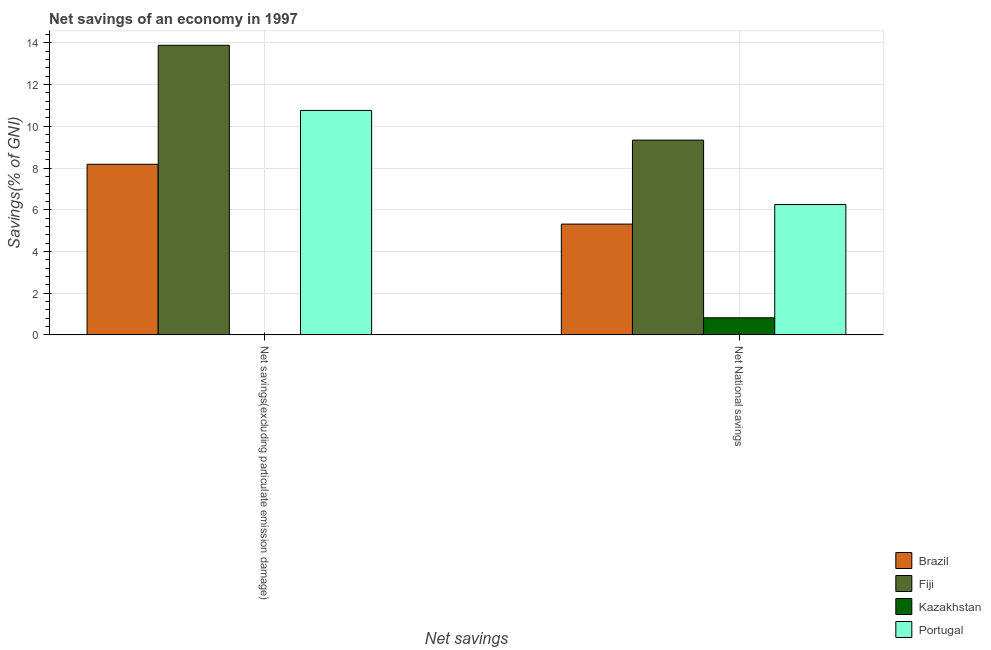How many bars are there on the 2nd tick from the left?
Your answer should be very brief. 4. How many bars are there on the 2nd tick from the right?
Offer a very short reply. 3. What is the label of the 1st group of bars from the left?
Your answer should be very brief. Net savings(excluding particulate emission damage). What is the net national savings in Fiji?
Ensure brevity in your answer.  9.34. Across all countries, what is the maximum net savings(excluding particulate emission damage)?
Your answer should be compact. 13.88. Across all countries, what is the minimum net savings(excluding particulate emission damage)?
Ensure brevity in your answer.  0. In which country was the net savings(excluding particulate emission damage) maximum?
Make the answer very short. Fiji. What is the total net savings(excluding particulate emission damage) in the graph?
Your answer should be compact. 32.82. What is the difference between the net savings(excluding particulate emission damage) in Fiji and that in Brazil?
Provide a succinct answer. 5.7. What is the difference between the net national savings in Fiji and the net savings(excluding particulate emission damage) in Portugal?
Make the answer very short. -1.42. What is the average net savings(excluding particulate emission damage) per country?
Keep it short and to the point. 8.21. What is the difference between the net savings(excluding particulate emission damage) and net national savings in Brazil?
Provide a succinct answer. 2.87. What is the ratio of the net national savings in Fiji to that in Brazil?
Ensure brevity in your answer.  1.76. Is the net national savings in Fiji less than that in Portugal?
Provide a short and direct response. No. In how many countries, is the net national savings greater than the average net national savings taken over all countries?
Provide a short and direct response. 2. How many bars are there?
Provide a short and direct response. 7. Are all the bars in the graph horizontal?
Give a very brief answer. No. Are the values on the major ticks of Y-axis written in scientific E-notation?
Offer a terse response. No. Does the graph contain grids?
Provide a short and direct response. Yes. Where does the legend appear in the graph?
Your response must be concise. Bottom right. How are the legend labels stacked?
Your response must be concise. Vertical. What is the title of the graph?
Keep it short and to the point. Net savings of an economy in 1997. What is the label or title of the X-axis?
Your response must be concise. Net savings. What is the label or title of the Y-axis?
Give a very brief answer. Savings(% of GNI). What is the Savings(% of GNI) of Brazil in Net savings(excluding particulate emission damage)?
Provide a succinct answer. 8.18. What is the Savings(% of GNI) of Fiji in Net savings(excluding particulate emission damage)?
Offer a terse response. 13.88. What is the Savings(% of GNI) of Kazakhstan in Net savings(excluding particulate emission damage)?
Your response must be concise. 0. What is the Savings(% of GNI) in Portugal in Net savings(excluding particulate emission damage)?
Your answer should be very brief. 10.76. What is the Savings(% of GNI) of Brazil in Net National savings?
Your answer should be compact. 5.31. What is the Savings(% of GNI) in Fiji in Net National savings?
Your answer should be very brief. 9.34. What is the Savings(% of GNI) of Kazakhstan in Net National savings?
Your answer should be very brief. 0.82. What is the Savings(% of GNI) of Portugal in Net National savings?
Your answer should be compact. 6.25. Across all Net savings, what is the maximum Savings(% of GNI) of Brazil?
Provide a succinct answer. 8.18. Across all Net savings, what is the maximum Savings(% of GNI) in Fiji?
Make the answer very short. 13.88. Across all Net savings, what is the maximum Savings(% of GNI) of Kazakhstan?
Your response must be concise. 0.82. Across all Net savings, what is the maximum Savings(% of GNI) of Portugal?
Offer a terse response. 10.76. Across all Net savings, what is the minimum Savings(% of GNI) of Brazil?
Ensure brevity in your answer.  5.31. Across all Net savings, what is the minimum Savings(% of GNI) in Fiji?
Keep it short and to the point. 9.34. Across all Net savings, what is the minimum Savings(% of GNI) of Kazakhstan?
Make the answer very short. 0. Across all Net savings, what is the minimum Savings(% of GNI) in Portugal?
Make the answer very short. 6.25. What is the total Savings(% of GNI) of Brazil in the graph?
Your response must be concise. 13.49. What is the total Savings(% of GNI) in Fiji in the graph?
Offer a terse response. 23.22. What is the total Savings(% of GNI) in Kazakhstan in the graph?
Your answer should be very brief. 0.82. What is the total Savings(% of GNI) of Portugal in the graph?
Provide a succinct answer. 17.01. What is the difference between the Savings(% of GNI) in Brazil in Net savings(excluding particulate emission damage) and that in Net National savings?
Make the answer very short. 2.87. What is the difference between the Savings(% of GNI) in Fiji in Net savings(excluding particulate emission damage) and that in Net National savings?
Ensure brevity in your answer.  4.55. What is the difference between the Savings(% of GNI) in Portugal in Net savings(excluding particulate emission damage) and that in Net National savings?
Give a very brief answer. 4.51. What is the difference between the Savings(% of GNI) of Brazil in Net savings(excluding particulate emission damage) and the Savings(% of GNI) of Fiji in Net National savings?
Ensure brevity in your answer.  -1.16. What is the difference between the Savings(% of GNI) of Brazil in Net savings(excluding particulate emission damage) and the Savings(% of GNI) of Kazakhstan in Net National savings?
Ensure brevity in your answer.  7.36. What is the difference between the Savings(% of GNI) in Brazil in Net savings(excluding particulate emission damage) and the Savings(% of GNI) in Portugal in Net National savings?
Make the answer very short. 1.93. What is the difference between the Savings(% of GNI) in Fiji in Net savings(excluding particulate emission damage) and the Savings(% of GNI) in Kazakhstan in Net National savings?
Provide a short and direct response. 13.06. What is the difference between the Savings(% of GNI) of Fiji in Net savings(excluding particulate emission damage) and the Savings(% of GNI) of Portugal in Net National savings?
Offer a very short reply. 7.63. What is the average Savings(% of GNI) of Brazil per Net savings?
Provide a short and direct response. 6.74. What is the average Savings(% of GNI) in Fiji per Net savings?
Provide a succinct answer. 11.61. What is the average Savings(% of GNI) of Kazakhstan per Net savings?
Give a very brief answer. 0.41. What is the average Savings(% of GNI) of Portugal per Net savings?
Offer a terse response. 8.5. What is the difference between the Savings(% of GNI) in Brazil and Savings(% of GNI) in Fiji in Net savings(excluding particulate emission damage)?
Make the answer very short. -5.7. What is the difference between the Savings(% of GNI) of Brazil and Savings(% of GNI) of Portugal in Net savings(excluding particulate emission damage)?
Ensure brevity in your answer.  -2.58. What is the difference between the Savings(% of GNI) in Fiji and Savings(% of GNI) in Portugal in Net savings(excluding particulate emission damage)?
Keep it short and to the point. 3.12. What is the difference between the Savings(% of GNI) of Brazil and Savings(% of GNI) of Fiji in Net National savings?
Your response must be concise. -4.03. What is the difference between the Savings(% of GNI) in Brazil and Savings(% of GNI) in Kazakhstan in Net National savings?
Your answer should be very brief. 4.49. What is the difference between the Savings(% of GNI) of Brazil and Savings(% of GNI) of Portugal in Net National savings?
Your answer should be very brief. -0.94. What is the difference between the Savings(% of GNI) in Fiji and Savings(% of GNI) in Kazakhstan in Net National savings?
Provide a short and direct response. 8.52. What is the difference between the Savings(% of GNI) in Fiji and Savings(% of GNI) in Portugal in Net National savings?
Offer a very short reply. 3.09. What is the difference between the Savings(% of GNI) in Kazakhstan and Savings(% of GNI) in Portugal in Net National savings?
Your answer should be compact. -5.43. What is the ratio of the Savings(% of GNI) in Brazil in Net savings(excluding particulate emission damage) to that in Net National savings?
Give a very brief answer. 1.54. What is the ratio of the Savings(% of GNI) in Fiji in Net savings(excluding particulate emission damage) to that in Net National savings?
Your answer should be compact. 1.49. What is the ratio of the Savings(% of GNI) of Portugal in Net savings(excluding particulate emission damage) to that in Net National savings?
Keep it short and to the point. 1.72. What is the difference between the highest and the second highest Savings(% of GNI) in Brazil?
Your response must be concise. 2.87. What is the difference between the highest and the second highest Savings(% of GNI) in Fiji?
Ensure brevity in your answer.  4.55. What is the difference between the highest and the second highest Savings(% of GNI) of Portugal?
Give a very brief answer. 4.51. What is the difference between the highest and the lowest Savings(% of GNI) in Brazil?
Provide a short and direct response. 2.87. What is the difference between the highest and the lowest Savings(% of GNI) of Fiji?
Offer a very short reply. 4.55. What is the difference between the highest and the lowest Savings(% of GNI) in Kazakhstan?
Your answer should be very brief. 0.82. What is the difference between the highest and the lowest Savings(% of GNI) of Portugal?
Your answer should be very brief. 4.51. 